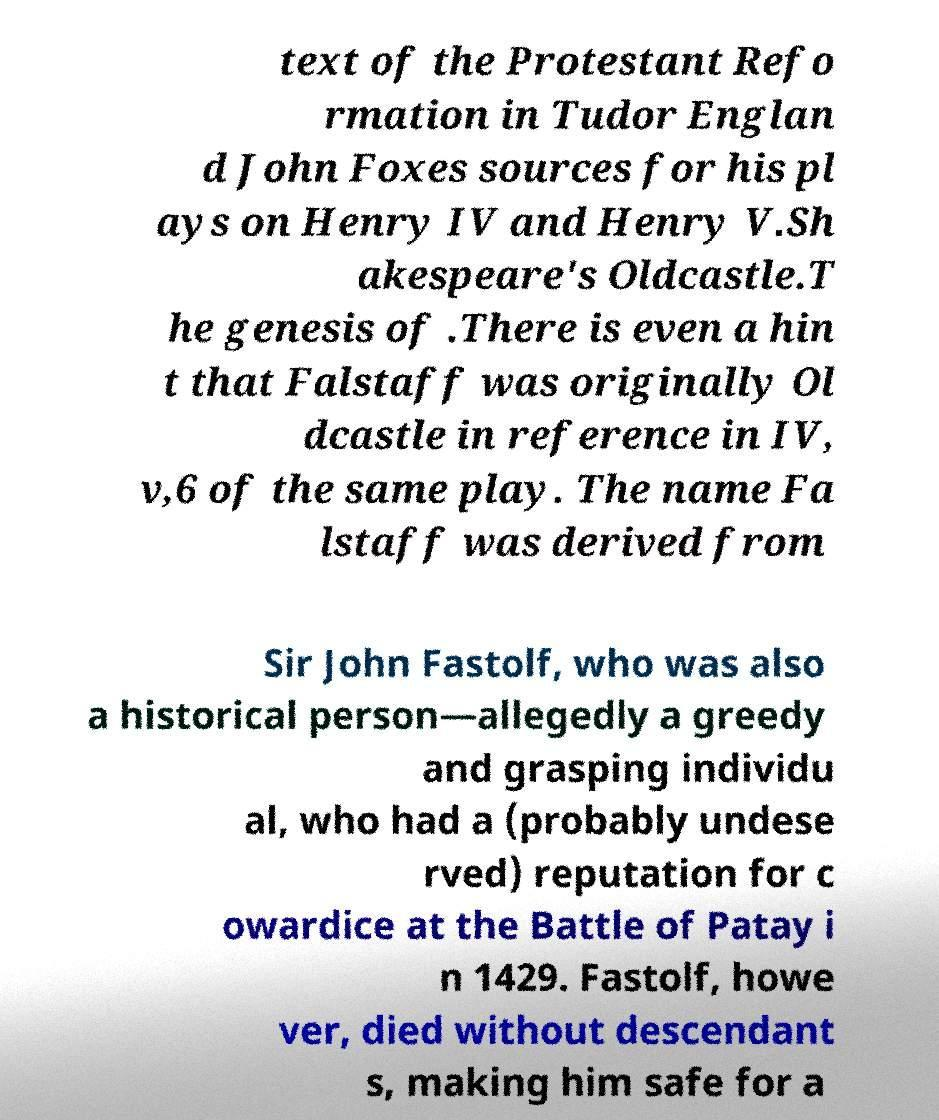Can you accurately transcribe the text from the provided image for me? text of the Protestant Refo rmation in Tudor Englan d John Foxes sources for his pl ays on Henry IV and Henry V.Sh akespeare's Oldcastle.T he genesis of .There is even a hin t that Falstaff was originally Ol dcastle in reference in IV, v,6 of the same play. The name Fa lstaff was derived from Sir John Fastolf, who was also a historical person—allegedly a greedy and grasping individu al, who had a (probably undese rved) reputation for c owardice at the Battle of Patay i n 1429. Fastolf, howe ver, died without descendant s, making him safe for a 